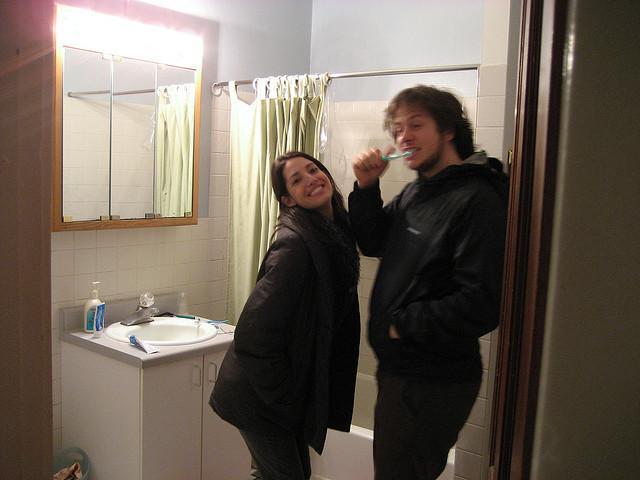How many people can you see?
Give a very brief answer. 2. 